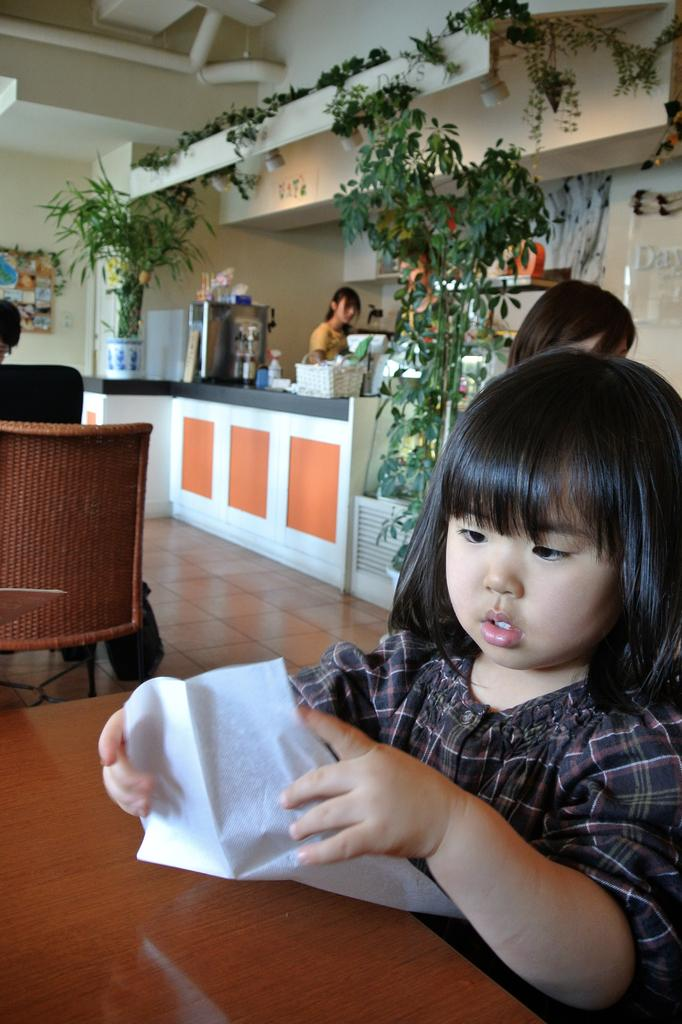Who is the main subject in the image? There is a girl in the image. What is the girl doing in the image? The girl is sitting on a chair. What other furniture is present in the image? There is a table in the image. What can be seen at the back side of the image? There is a flower pot at the back side of the image. What type of beam is holding up the ceiling in the image? There is no beam visible in the image; it does not show the ceiling or any structural elements. 